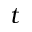<formula> <loc_0><loc_0><loc_500><loc_500>t</formula> 